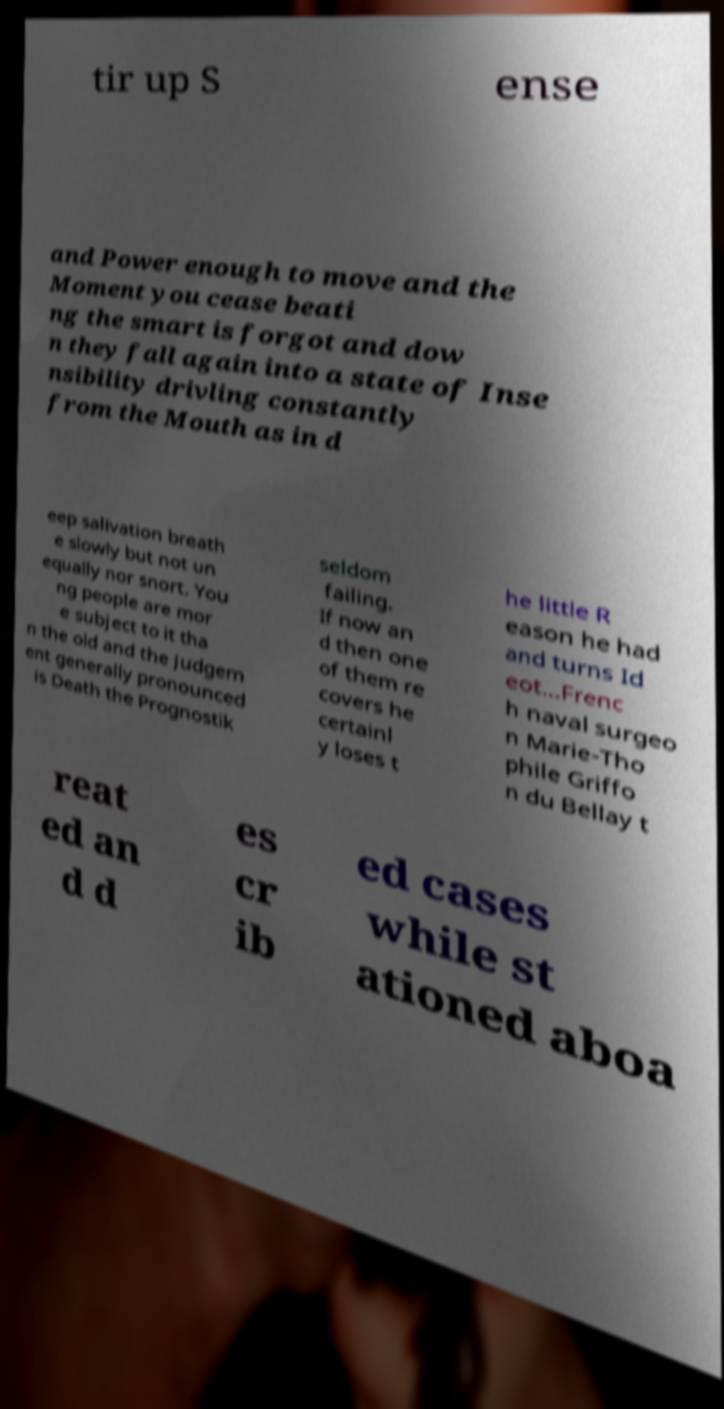Can you accurately transcribe the text from the provided image for me? tir up S ense and Power enough to move and the Moment you cease beati ng the smart is forgot and dow n they fall again into a state of Inse nsibility drivling constantly from the Mouth as in d eep salivation breath e slowly but not un equally nor snort. You ng people are mor e subject to it tha n the old and the Judgem ent generally pronounced is Death the Prognostik seldom failing. If now an d then one of them re covers he certainl y loses t he little R eason he had and turns Id eot...Frenc h naval surgeo n Marie-Tho phile Griffo n du Bellay t reat ed an d d es cr ib ed cases while st ationed aboa 